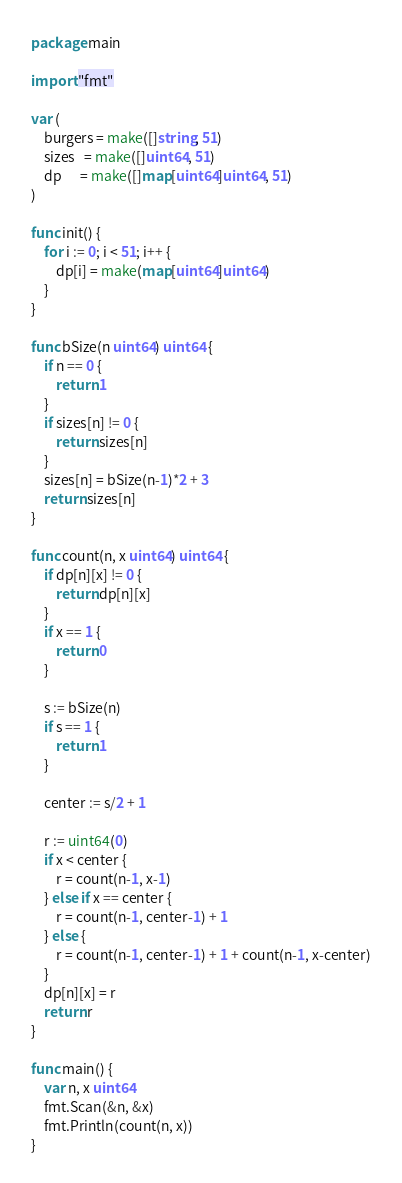Convert code to text. <code><loc_0><loc_0><loc_500><loc_500><_Go_>package main

import "fmt"

var (
	burgers = make([]string, 51)
	sizes   = make([]uint64, 51)
	dp      = make([]map[uint64]uint64, 51)
)

func init() {
	for i := 0; i < 51; i++ {
		dp[i] = make(map[uint64]uint64)
	}
}

func bSize(n uint64) uint64 {
	if n == 0 {
		return 1
	}
	if sizes[n] != 0 {
		return sizes[n]
	}
	sizes[n] = bSize(n-1)*2 + 3
	return sizes[n]
}

func count(n, x uint64) uint64 {
	if dp[n][x] != 0 {
		return dp[n][x]
	}
	if x == 1 {
		return 0
	}

	s := bSize(n)
	if s == 1 {
		return 1
	}

	center := s/2 + 1

	r := uint64(0)
	if x < center {
		r = count(n-1, x-1)
	} else if x == center {
		r = count(n-1, center-1) + 1
	} else {
		r = count(n-1, center-1) + 1 + count(n-1, x-center)
	}
	dp[n][x] = r
	return r
}

func main() {
	var n, x uint64
	fmt.Scan(&n, &x)
	fmt.Println(count(n, x))
}</code> 